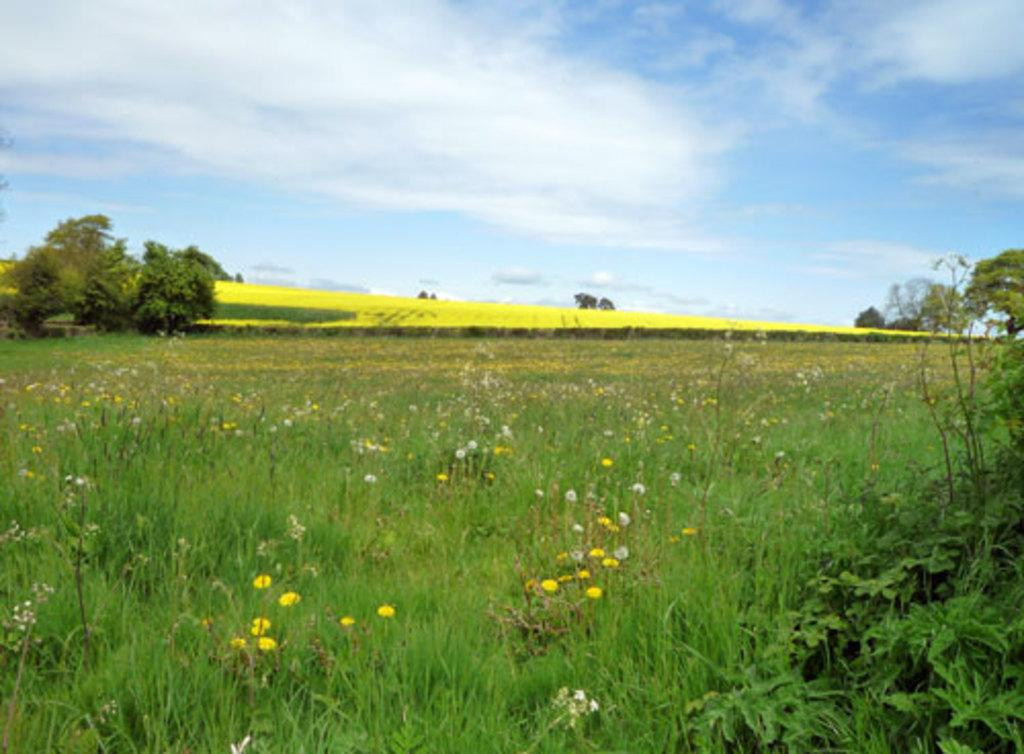What type of vegetation can be seen in the grass in the image? There are flowers in the grass in the image. Where are the flowers located in relation to the image? The flowers are on the down side of the image. What can be seen on the left side of the image? There are trees on the left side of the image. What color is the sky in the image? The sky is blue and visible at the top of the image. How many visitors are present in the image? There is no indication of any visitors in the image. What type of stitch is used to create the flowers in the image? The flowers in the image are real, not stitched, so there is no stitching involved. 